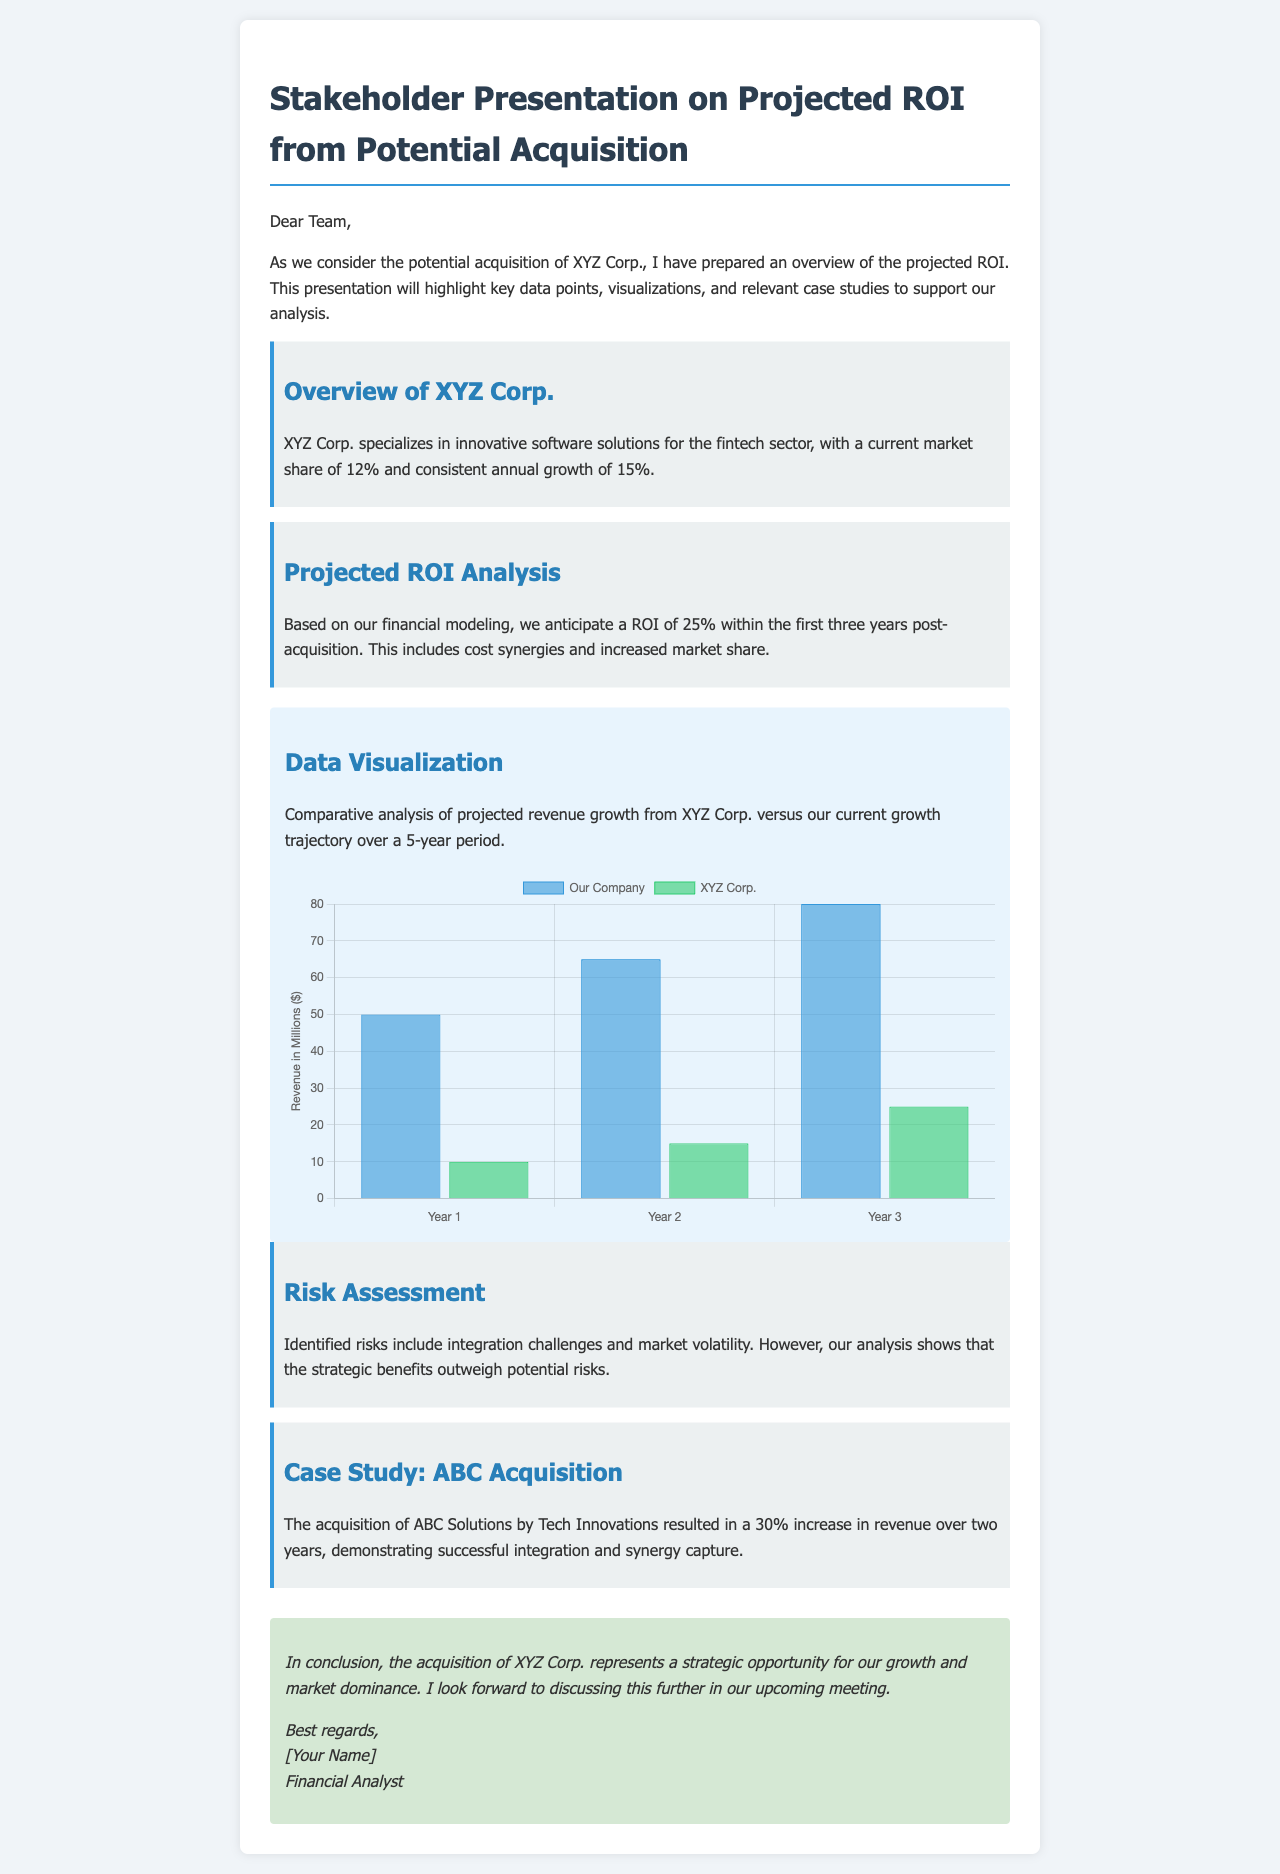What is the current market share of XYZ Corp.? The document states that XYZ Corp. has a current market share of 12%.
Answer: 12% What is the anticipated ROI within the first three years post-acquisition? The anticipated ROI presented is 25% within the first three years post-acquisition.
Answer: 25% Which corporation was used as a case study in this document? The case study highlighted in the document is about ABC Solutions.
Answer: ABC Solutions What is the percentage increase in revenue from the ABC acquisition case study? The document notes a 30% increase in revenue from the acquisition of ABC Solutions.
Answer: 30% What growth rate does XYZ Corp. achieve annually? XYZ Corp. is stated to have a consistent annual growth rate of 15%.
Answer: 15% What is the projected revenue for "Our Company" in Year 3 according to the visualization? The visualization indicates projected revenue of 80 million dollars for "Our Company" in Year 3.
Answer: 80 million What are the identified risks associated with the potential acquisition? The document mentions integration challenges and market volatility as identified risks.
Answer: Integration challenges and market volatility What is the title of this document? The title indicated in the document is "Stakeholder Presentation on Projected ROI from Potential Acquisition."
Answer: Stakeholder Presentation on Projected ROI from Potential Acquisition What is the background color of the data visualization section? The background color of the data visualization section is light blue, specifically noted in the style as #e8f4fd.
Answer: Light blue 